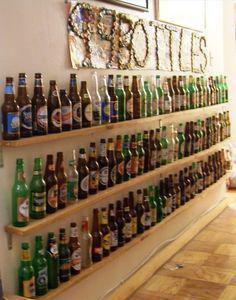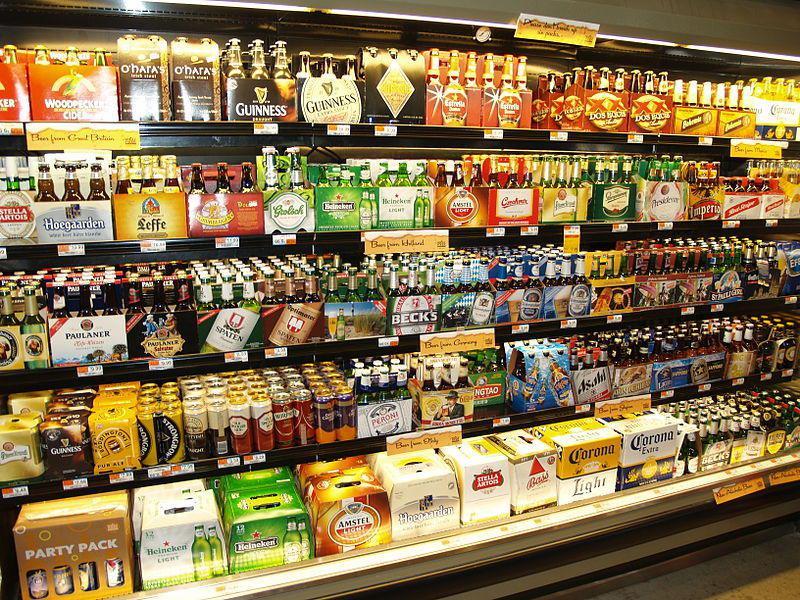The first image is the image on the left, the second image is the image on the right. Examine the images to the left and right. Is the description "The bottles in one of the images do not have caps." accurate? Answer yes or no. Yes. 